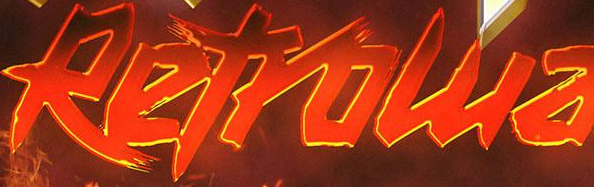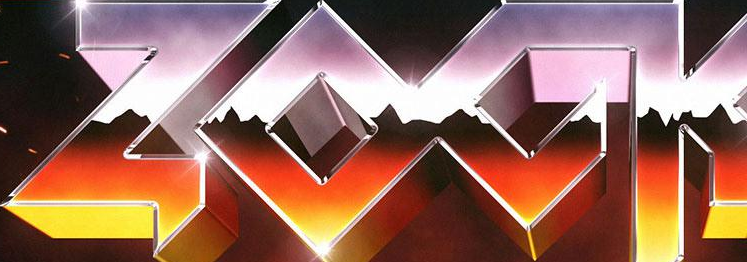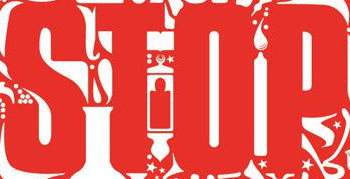Read the text from these images in sequence, separated by a semicolon. Retrowa; ZOCK; STOP 